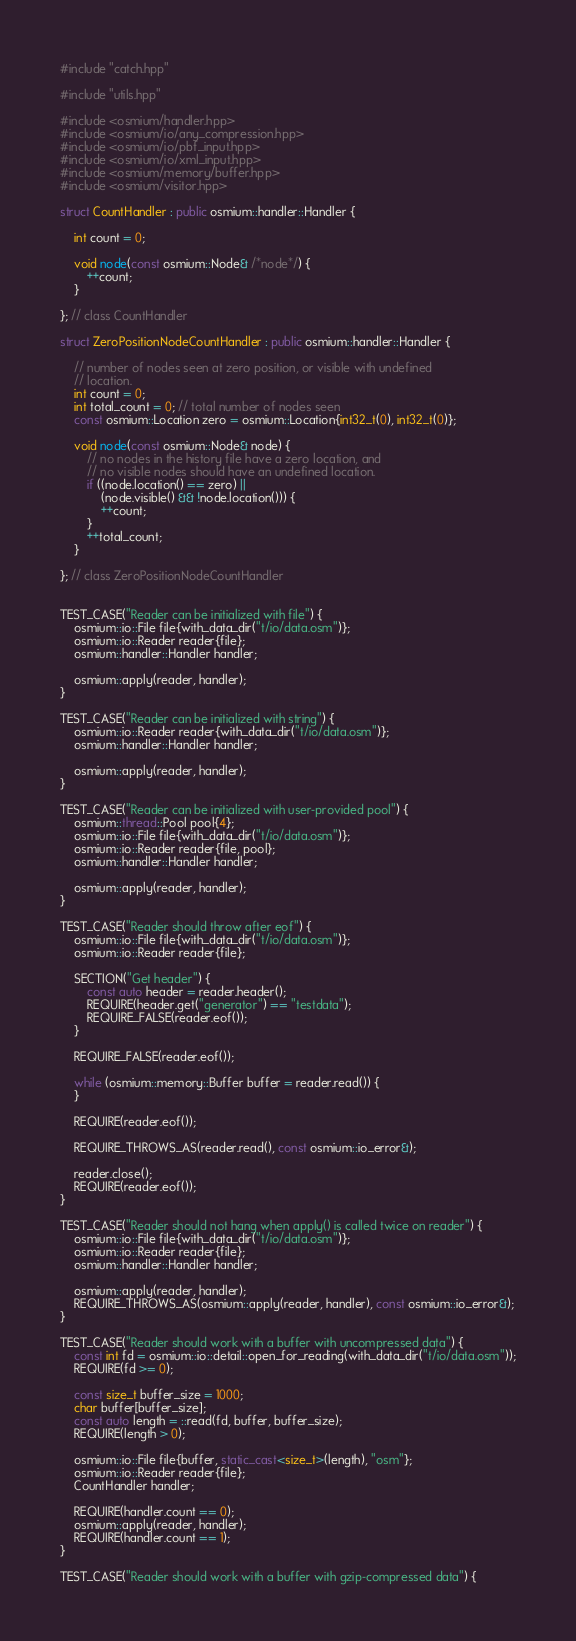Convert code to text. <code><loc_0><loc_0><loc_500><loc_500><_C++_>#include "catch.hpp"

#include "utils.hpp"

#include <osmium/handler.hpp>
#include <osmium/io/any_compression.hpp>
#include <osmium/io/pbf_input.hpp>
#include <osmium/io/xml_input.hpp>
#include <osmium/memory/buffer.hpp>
#include <osmium/visitor.hpp>

struct CountHandler : public osmium::handler::Handler {

    int count = 0;

    void node(const osmium::Node& /*node*/) {
        ++count;
    }

}; // class CountHandler

struct ZeroPositionNodeCountHandler : public osmium::handler::Handler {

    // number of nodes seen at zero position, or visible with undefined
    // location.
    int count = 0;
    int total_count = 0; // total number of nodes seen
    const osmium::Location zero = osmium::Location{int32_t(0), int32_t(0)};

    void node(const osmium::Node& node) {
        // no nodes in the history file have a zero location, and
        // no visible nodes should have an undefined location.
        if ((node.location() == zero) ||
            (node.visible() && !node.location())) {
            ++count;
        }
        ++total_count;
    }

}; // class ZeroPositionNodeCountHandler


TEST_CASE("Reader can be initialized with file") {
    osmium::io::File file{with_data_dir("t/io/data.osm")};
    osmium::io::Reader reader{file};
    osmium::handler::Handler handler;

    osmium::apply(reader, handler);
}

TEST_CASE("Reader can be initialized with string") {
    osmium::io::Reader reader{with_data_dir("t/io/data.osm")};
    osmium::handler::Handler handler;

    osmium::apply(reader, handler);
}

TEST_CASE("Reader can be initialized with user-provided pool") {
    osmium::thread::Pool pool{4};
    osmium::io::File file{with_data_dir("t/io/data.osm")};
    osmium::io::Reader reader{file, pool};
    osmium::handler::Handler handler;

    osmium::apply(reader, handler);
}

TEST_CASE("Reader should throw after eof") {
    osmium::io::File file{with_data_dir("t/io/data.osm")};
    osmium::io::Reader reader{file};

    SECTION("Get header") {
        const auto header = reader.header();
        REQUIRE(header.get("generator") == "testdata");
        REQUIRE_FALSE(reader.eof());
    }

    REQUIRE_FALSE(reader.eof());

    while (osmium::memory::Buffer buffer = reader.read()) {
    }

    REQUIRE(reader.eof());

    REQUIRE_THROWS_AS(reader.read(), const osmium::io_error&);

    reader.close();
    REQUIRE(reader.eof());
}

TEST_CASE("Reader should not hang when apply() is called twice on reader") {
    osmium::io::File file{with_data_dir("t/io/data.osm")};
    osmium::io::Reader reader{file};
    osmium::handler::Handler handler;

    osmium::apply(reader, handler);
    REQUIRE_THROWS_AS(osmium::apply(reader, handler), const osmium::io_error&);
}

TEST_CASE("Reader should work with a buffer with uncompressed data") {
    const int fd = osmium::io::detail::open_for_reading(with_data_dir("t/io/data.osm"));
    REQUIRE(fd >= 0);

    const size_t buffer_size = 1000;
    char buffer[buffer_size];
    const auto length = ::read(fd, buffer, buffer_size);
    REQUIRE(length > 0);

    osmium::io::File file{buffer, static_cast<size_t>(length), "osm"};
    osmium::io::Reader reader{file};
    CountHandler handler;

    REQUIRE(handler.count == 0);
    osmium::apply(reader, handler);
    REQUIRE(handler.count == 1);
}

TEST_CASE("Reader should work with a buffer with gzip-compressed data") {</code> 